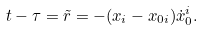Convert formula to latex. <formula><loc_0><loc_0><loc_500><loc_500>t - \tau = \tilde { r } = - ( x _ { i } - x _ { 0 i } ) \dot { x } _ { 0 } ^ { i } .</formula> 